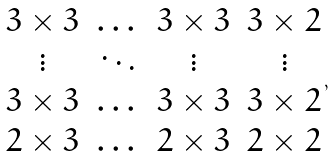Convert formula to latex. <formula><loc_0><loc_0><loc_500><loc_500>\begin{matrix} 3 \times 3 & \dots & 3 \times 3 & 3 \times 2 \\ \vdots & \ddots & \vdots & \vdots \\ 3 \times 3 & \dots & 3 \times 3 & 3 \times 2 \\ 2 \times 3 & \dots & 2 \times 3 & 2 \times 2 \\ \end{matrix} \, ,</formula> 